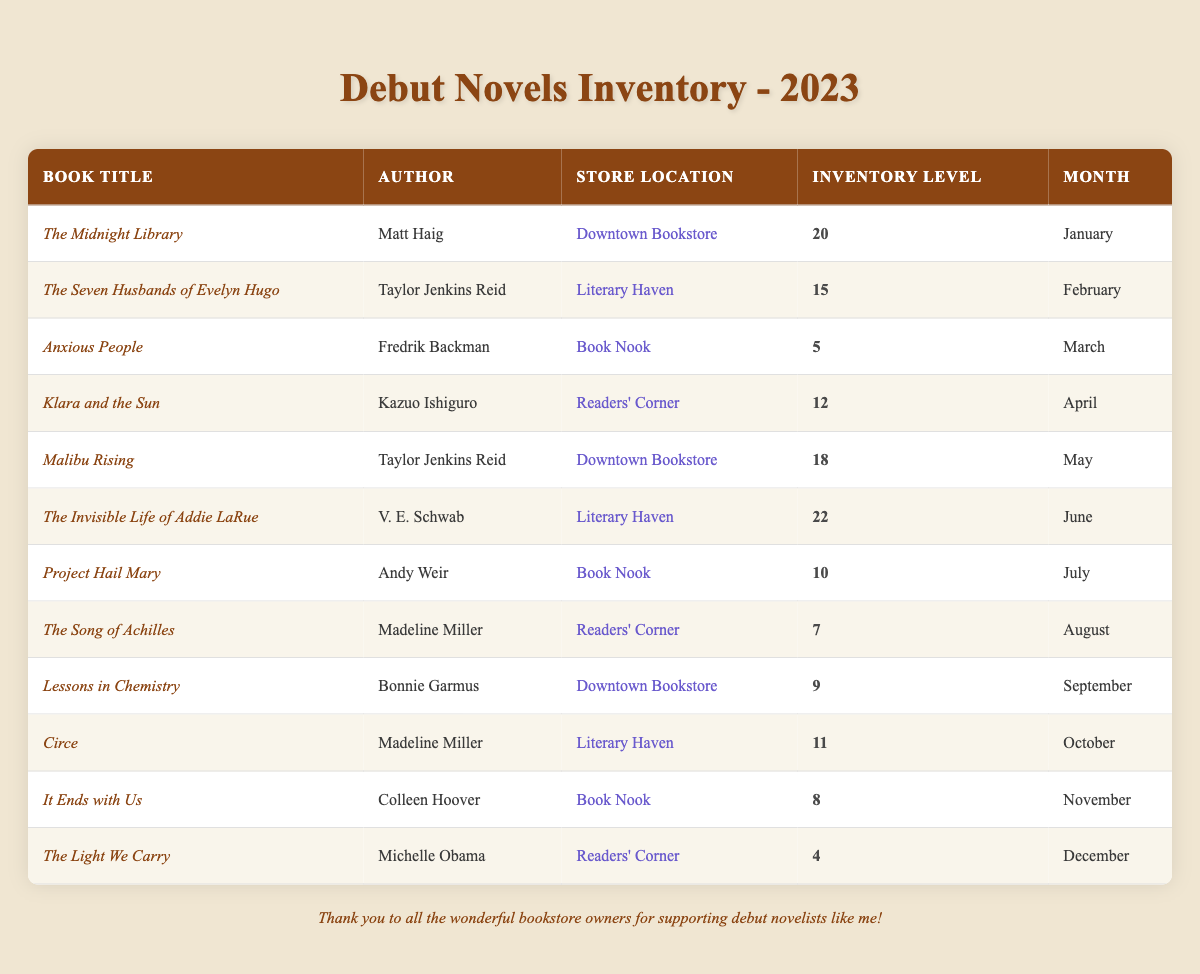What was the inventory level of "The Invisible Life of Addie LaRue"? The table shows that the inventory level for "The Invisible Life of Addie LaRue" at Literary Haven in June 2023 was 22.
Answer: 22 In which month did "Lessons in Chemistry" have an inventory level of 9? According to the table, "Lessons in Chemistry" had an inventory level of 9 in September 2023 at Downtown Bookstore.
Answer: September What is the total inventory level for debut novels in the month of March? The only entry in March is "Anxious People," which has an inventory level of 5. Therefore, the total inventory for March is 5.
Answer: 5 Who is the author of "The Seven Husbands of Evelyn Hugo"? The table indicates that "The Seven Husbands of Evelyn Hugo" was written by Taylor Jenkins Reid.
Answer: Taylor Jenkins Reid Was there any month in 2023 where "The Light We Carry" had an inventory level of more than 4? Yes, "The Light We Carry" had an inventory level of 4 in December, which is not more than 4, so there was no month with an inventory level higher than 4 for this book.
Answer: No Which store had the highest inventory level for debut novels in June? In June 2023, Literary Haven had "The Invisible Life of Addie LaRue" with the highest inventory level of 22.
Answer: Literary Haven What is the average inventory level of books at Book Nook for the year? The inventory levels for Book Nook across the year are 5 (March), 10 (July), and 8 (November). Adding these gives 23, and there are three entries. Therefore, the average is 23/3 = 7.67, which rounds to 8.
Answer: 8 How many books had an inventory level of less than 10 across the year? The titles with inventory levels less than 10 are "Anxious People" (5), "The Song of Achilles" (7), "It Ends with Us" (8), and "The Light We Carry" (4), totaling 4 books.
Answer: 4 What is the difference in inventory levels between the highest and lowest entries in the table? The highest inventory level is 22 from "The Invisible Life of Addie LaRue" in June at Literary Haven, and the lowest is 4 for "The Light We Carry" in December at Readers' Corner. The difference is 22 - 4 = 18.
Answer: 18 Which author had the most books listed in this inventory table? Taylor Jenkins Reid appears twice in the table with "The Seven Husbands of Evelyn Hugo" and "Malibu Rising," which is more than any other author.
Answer: Taylor Jenkins Reid 